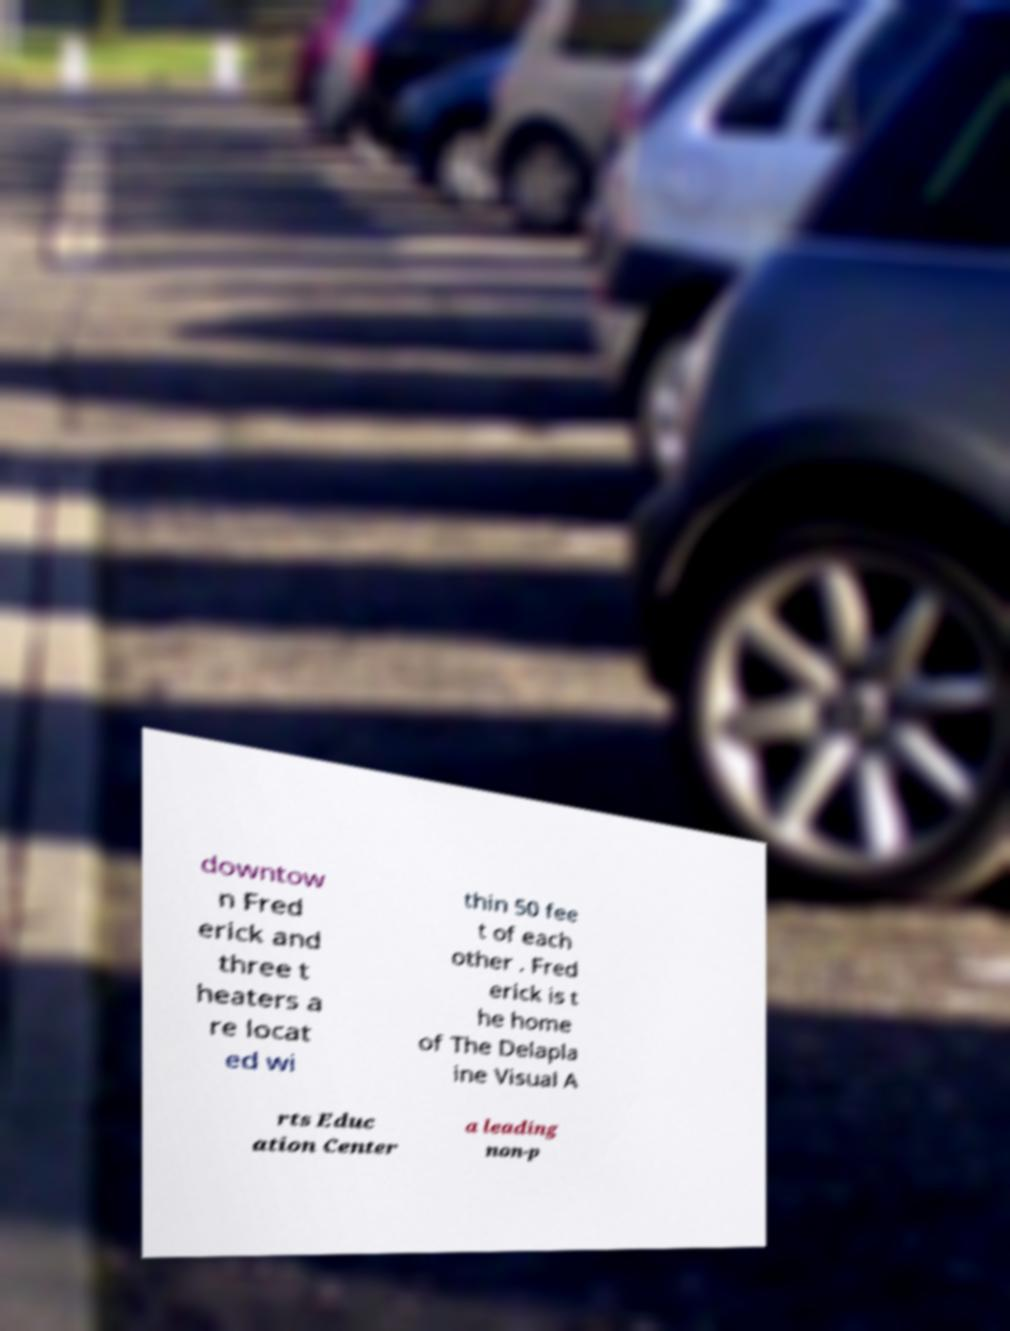Could you extract and type out the text from this image? downtow n Fred erick and three t heaters a re locat ed wi thin 50 fee t of each other . Fred erick is t he home of The Delapla ine Visual A rts Educ ation Center a leading non-p 